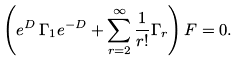<formula> <loc_0><loc_0><loc_500><loc_500>\left ( e ^ { D } \, \Gamma _ { 1 } e ^ { - D } + \sum _ { r = 2 } ^ { \infty } \frac { 1 } { r ! } \Gamma _ { r } \right ) F = 0 .</formula> 